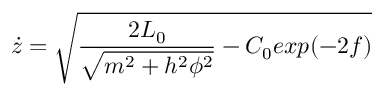Convert formula to latex. <formula><loc_0><loc_0><loc_500><loc_500>\dot { z } = \sqrt { \frac { 2 L _ { 0 } } { \sqrt { m ^ { 2 } + h ^ { 2 } \phi ^ { 2 } } } - C _ { 0 } e x p ( - 2 f ) }</formula> 